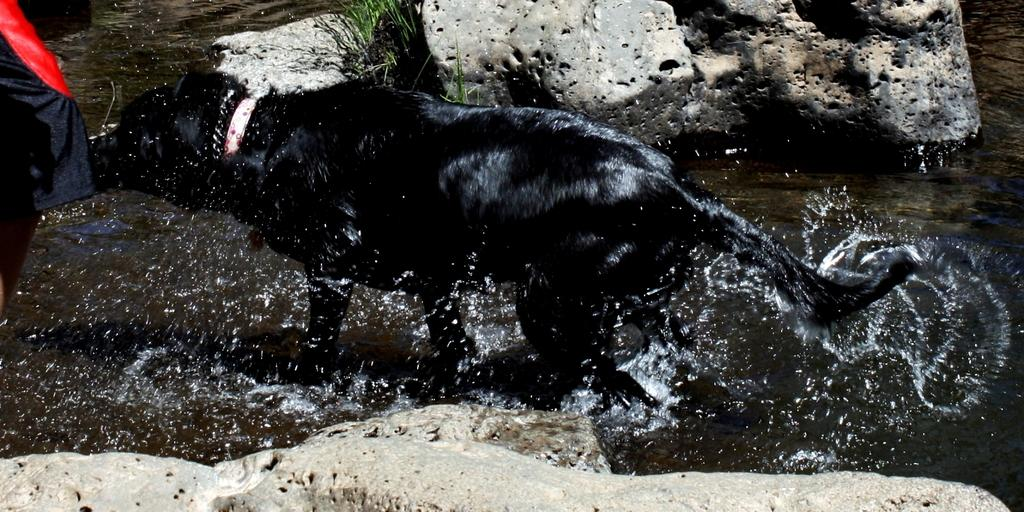What animal can be seen in the image? There is a dog in the image. What is the dog doing in the image? The dog is walking in the water. What is the color of the dog? The dog is black in color. What type of terrain is visible in the image? There are stones and grass visible in the image. What type of scissors can be seen cutting the grass in the image? There are no scissors present in the image; the dog is walking in the water, and there is grass visible, but no scissors are cutting it. 